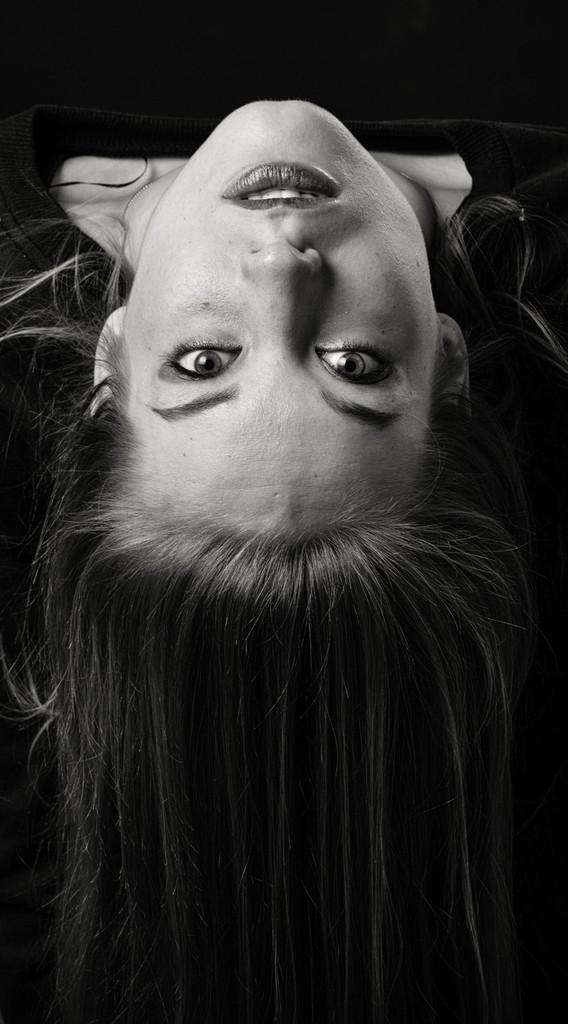Who is present in the image? There is a woman in the image. What can be seen behind the woman? The background of the image is black. What type of hat is the woman wearing in the image? There is no hat visible in the image. Can you describe the field in the background of the image? There is no field present in the image; the background is black. 